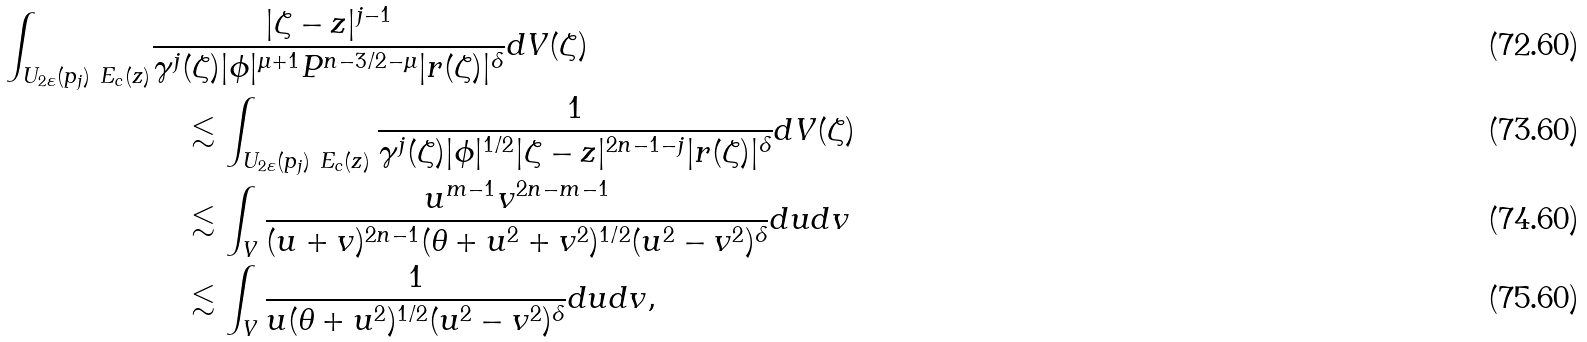<formula> <loc_0><loc_0><loc_500><loc_500>\int _ { U _ { 2 \varepsilon } ( p _ { j } ) \ E _ { c } ( z ) } & \frac { | \zeta - z | ^ { j - 1 } } { \gamma ^ { j } ( \zeta ) | \phi | ^ { \mu + 1 } P ^ { n - 3 / 2 - \mu } | r ( \zeta ) | ^ { \delta } } d V ( \zeta ) \\ & \quad \lesssim \int _ { U _ { 2 \varepsilon } ( p _ { j } ) \ E _ { c } ( z ) } \frac { 1 } { \gamma ^ { j } ( \zeta ) | \phi | ^ { 1 / 2 } | \zeta - z | ^ { 2 n - 1 - j } | r ( \zeta ) | ^ { \delta } } d V ( \zeta ) \\ & \quad \lesssim \int _ { V } \frac { u ^ { m - 1 } v ^ { 2 n - m - 1 } } { ( u + v ) ^ { 2 n - 1 } ( \theta + u ^ { 2 } + v ^ { 2 } ) ^ { 1 / 2 } ( u ^ { 2 } - v ^ { 2 } ) ^ { \delta } } d u d v \\ & \quad \lesssim \int _ { V } \frac { 1 } { u ( \theta + u ^ { 2 } ) ^ { 1 / 2 } ( u ^ { 2 } - v ^ { 2 } ) ^ { \delta } } d u d v ,</formula> 